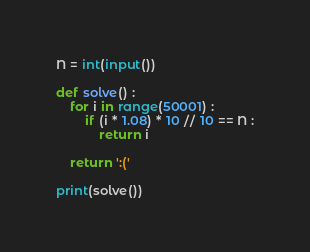Convert code to text. <code><loc_0><loc_0><loc_500><loc_500><_Python_>N = int(input())

def solve() :
    for i in range(50001) :
        if (i * 1.08) * 10 // 10 == N :
            return i
    
    return ':('
    
print(solve())</code> 